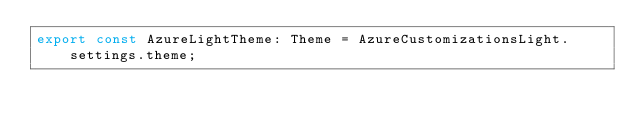Convert code to text. <code><loc_0><loc_0><loc_500><loc_500><_TypeScript_>export const AzureLightTheme: Theme = AzureCustomizationsLight.settings.theme;
</code> 